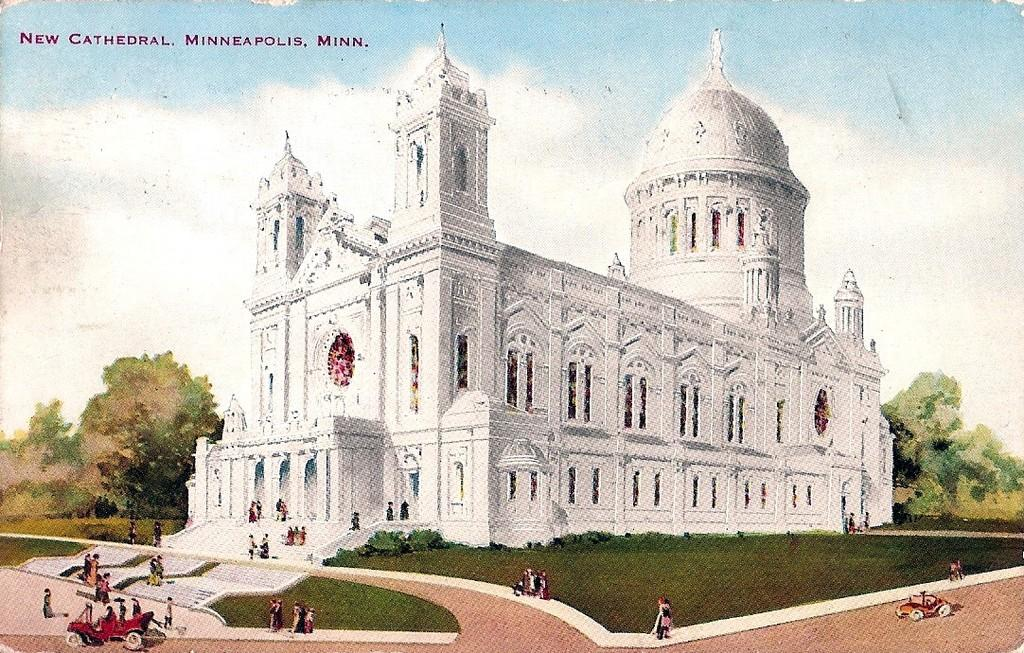What type of structure is present in the image? There is a building in the image. Who or what can be seen in the image besides the building? There are people and vehicles in the image. What type of natural elements are present in the image? There are trees and grass in the image. What architectural feature can be seen on the building? There are windows in the image. What is visible in the background of the image? The sky is visible in the background of the image, and there are clouds in the sky. What type of cherries can be seen growing on the building in the image? There are no cherries present in the image, and they are not growing on the building. 